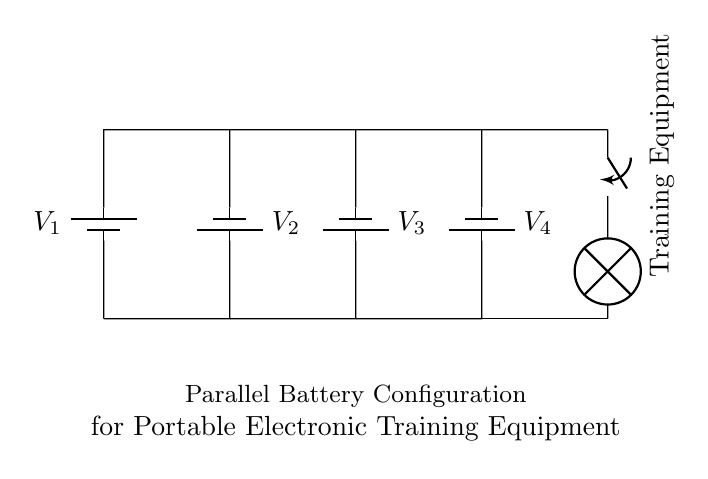What type of circuit is this? This circuit is a parallel configuration, as indicated by the multiple batteries connected alongside each other. Each battery is connected to the same two points, allowing the same voltage across them while sharing the total current.
Answer: Parallel How many batteries are in the circuit? The circuit diagram shows a total of four batteries labeled V1, V2, V3, and V4 arranged in parallel.
Answer: Four What is the function of the switch in the circuit? The switch controls the connection between the batteries and the training equipment, allowing the user to turn the equipment on or off as needed. When the switch is closed, the current flows to the training equipment.
Answer: Control What voltage do the batteries supply? Each battery in the diagram can be presumed to have the same voltage, though it's not specified. In a typical parallel circuit, the voltage remains constant across each component.
Answer: Constant What is connected to the output of the circuit? The output of the circuit is connected to a lamp labeled as "Training Equipment," indicating that this is the device powered by the batteries in the circuit configuration.
Answer: Training Equipment What happens to the total current in a parallel circuit? In a parallel circuit, the total current is the sum of the currents through each parallel branch, which is amplified since each battery contributes to the overall current.
Answer: Sum What is the relationship between voltage and battery configuration in this circuit? In a parallel configuration, the voltage across all connected batteries is equal to the voltage of a single battery, which ensures that the training equipment receives a consistent voltage supply regardless of the number of batteries used.
Answer: Equal 